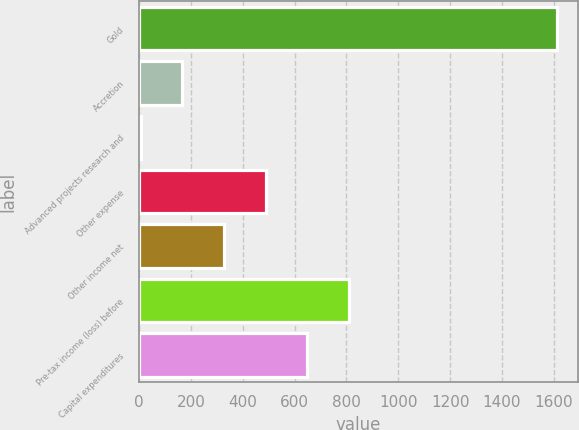<chart> <loc_0><loc_0><loc_500><loc_500><bar_chart><fcel>Gold<fcel>Accretion<fcel>Advanced projects research and<fcel>Other expense<fcel>Other income net<fcel>Pre-tax income (loss) before<fcel>Capital expenditures<nl><fcel>1613<fcel>166.7<fcel>6<fcel>488.1<fcel>327.4<fcel>809.5<fcel>648.8<nl></chart> 